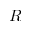<formula> <loc_0><loc_0><loc_500><loc_500>R</formula> 